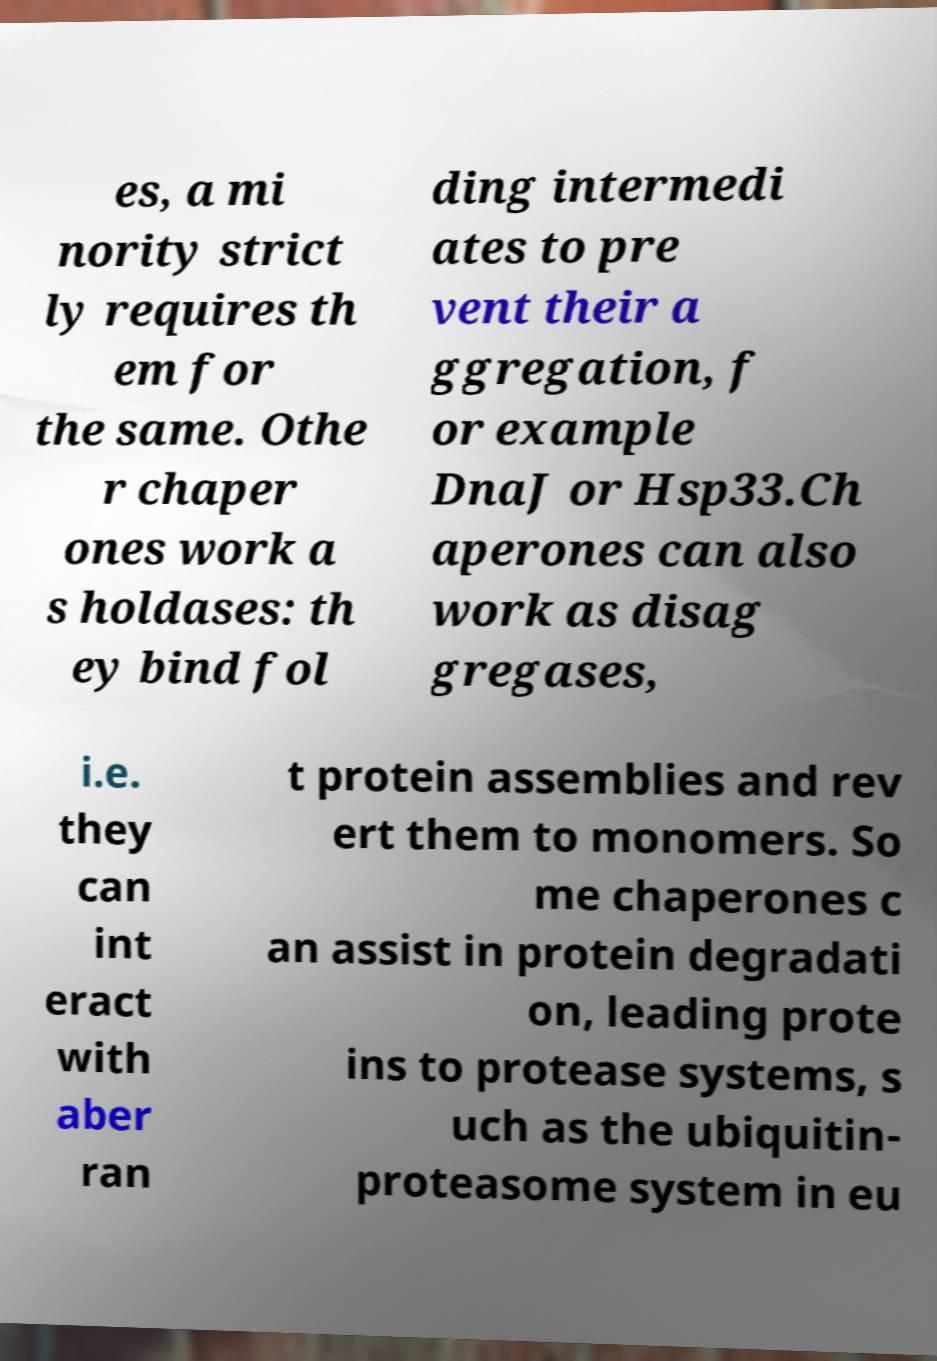Could you extract and type out the text from this image? es, a mi nority strict ly requires th em for the same. Othe r chaper ones work a s holdases: th ey bind fol ding intermedi ates to pre vent their a ggregation, f or example DnaJ or Hsp33.Ch aperones can also work as disag gregases, i.e. they can int eract with aber ran t protein assemblies and rev ert them to monomers. So me chaperones c an assist in protein degradati on, leading prote ins to protease systems, s uch as the ubiquitin- proteasome system in eu 